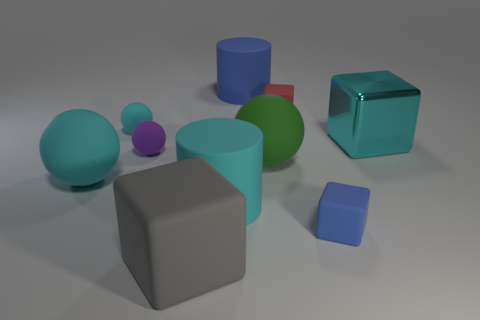Is the big cylinder in front of the big green object made of the same material as the big cube that is to the right of the gray cube?
Your answer should be very brief. No. Are there more cyan spheres in front of the cyan block than blue cubes that are behind the big blue rubber cylinder?
Your answer should be very brief. Yes. The gray thing that is the same size as the green sphere is what shape?
Give a very brief answer. Cube. What number of objects are either tiny yellow things or big cubes right of the red block?
Give a very brief answer. 1. Do the large matte cube and the shiny thing have the same color?
Ensure brevity in your answer.  No. How many metallic cubes are in front of the green thing?
Your response must be concise. 0. What color is the large cube that is the same material as the tiny red thing?
Provide a succinct answer. Gray. How many matte things are either large blocks or things?
Provide a short and direct response. 9. Does the cyan cube have the same material as the small red cube?
Your response must be concise. No. What is the shape of the tiny thing that is in front of the green rubber object?
Your response must be concise. Cube. 